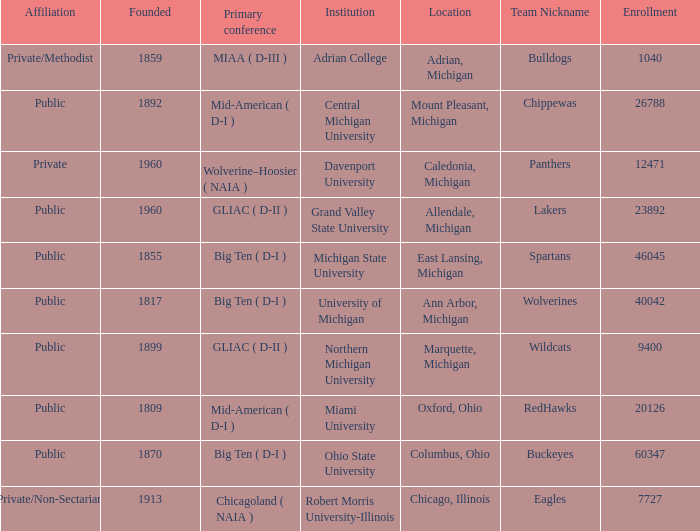How many primary conferences were held in Allendale, Michigan? 1.0. 